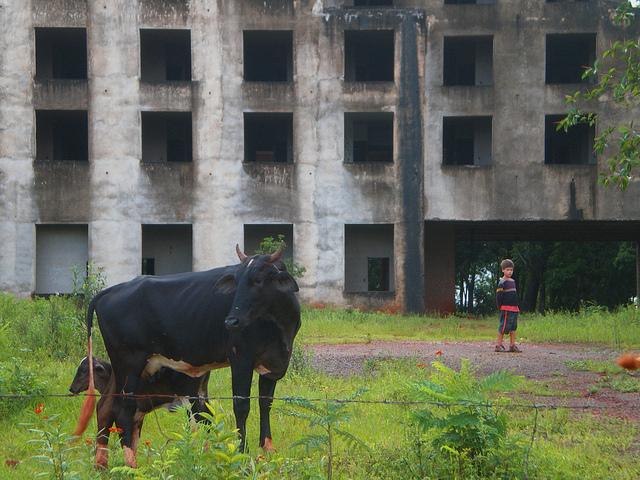Is this cow giving birth right now?
Keep it brief. No. Is this in the city?
Short answer required. No. Are the cows looking in the same direction?
Concise answer only. No. 